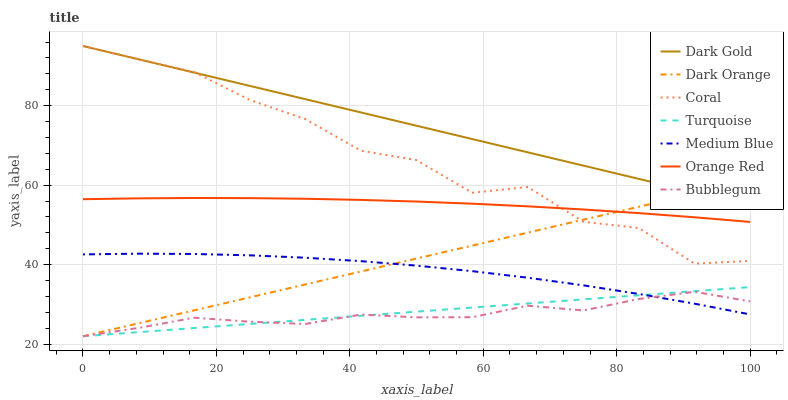Does Turquoise have the minimum area under the curve?
Answer yes or no. No. Does Turquoise have the maximum area under the curve?
Answer yes or no. No. Is Turquoise the smoothest?
Answer yes or no. No. Is Turquoise the roughest?
Answer yes or no. No. Does Dark Gold have the lowest value?
Answer yes or no. No. Does Turquoise have the highest value?
Answer yes or no. No. Is Medium Blue less than Coral?
Answer yes or no. Yes. Is Orange Red greater than Turquoise?
Answer yes or no. Yes. Does Medium Blue intersect Coral?
Answer yes or no. No. 